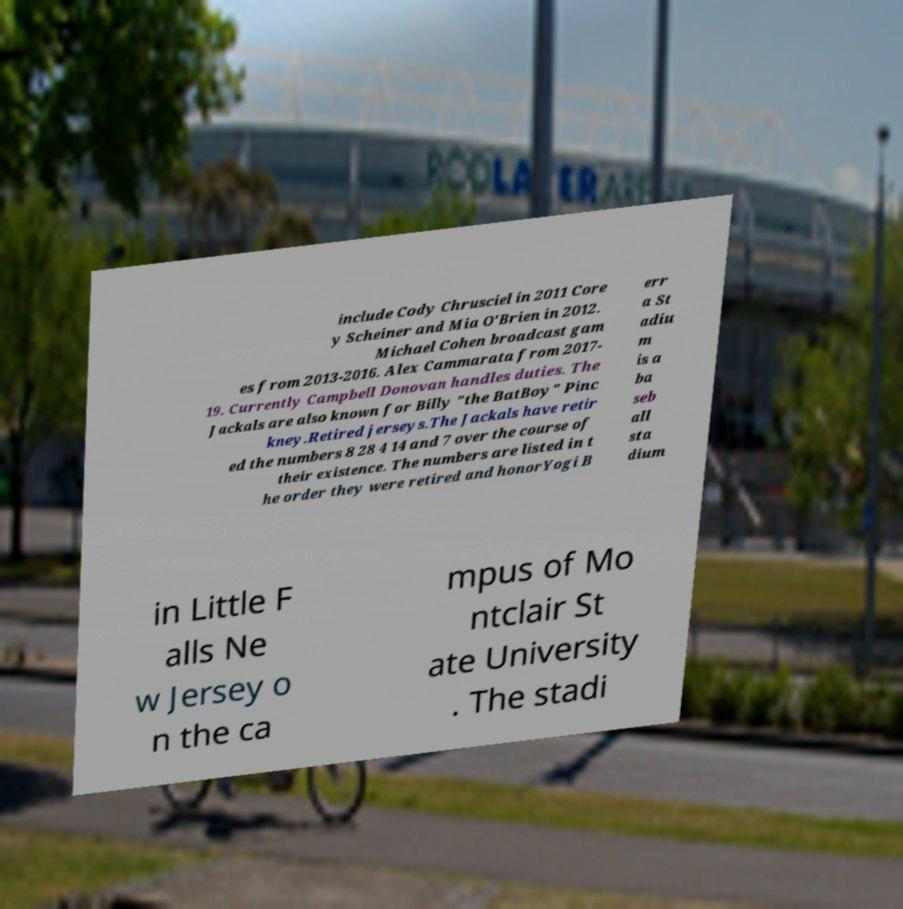For documentation purposes, I need the text within this image transcribed. Could you provide that? include Cody Chrusciel in 2011 Core y Scheiner and Mia O'Brien in 2012. Michael Cohen broadcast gam es from 2013-2016. Alex Cammarata from 2017- 19. Currently Campbell Donovan handles duties. The Jackals are also known for Billy "the BatBoy" Pinc kney.Retired jerseys.The Jackals have retir ed the numbers 8 28 4 14 and 7 over the course of their existence. The numbers are listed in t he order they were retired and honorYogi B err a St adiu m is a ba seb all sta dium in Little F alls Ne w Jersey o n the ca mpus of Mo ntclair St ate University . The stadi 